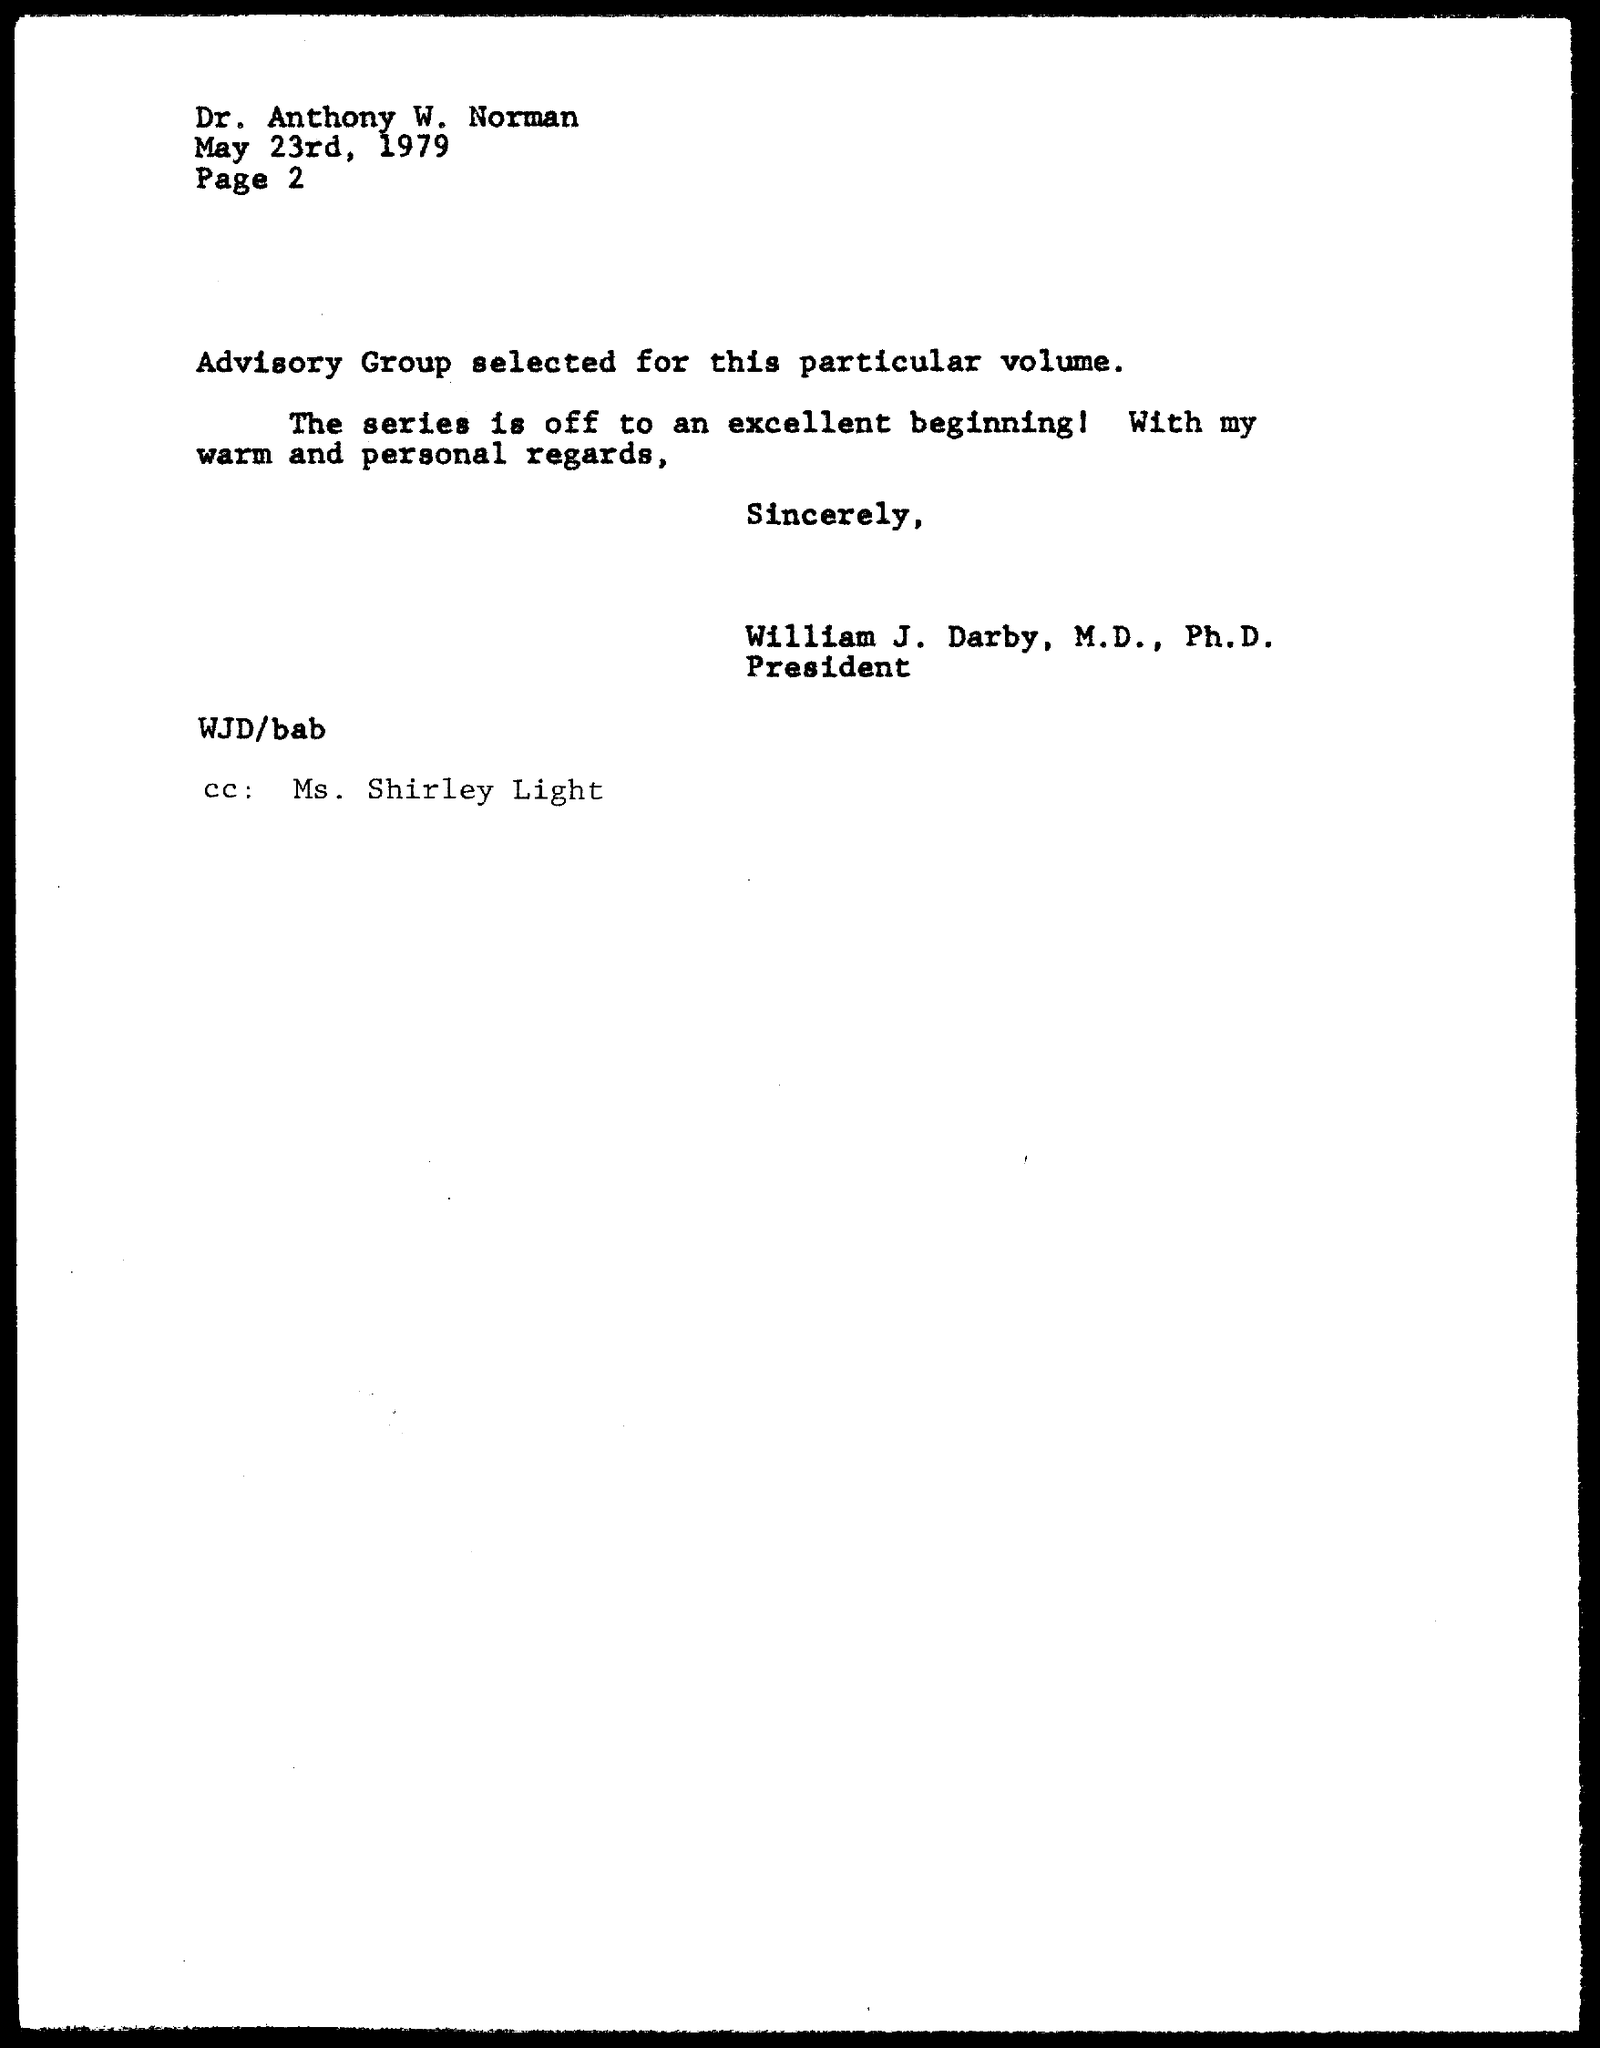Mention a couple of crucial points in this snapshot. The memorandum is addressed to Dr. Anthony W. Norman. The memorandum is dated May 23, 1979. The "CC" address is Ms. Shirley Light. 